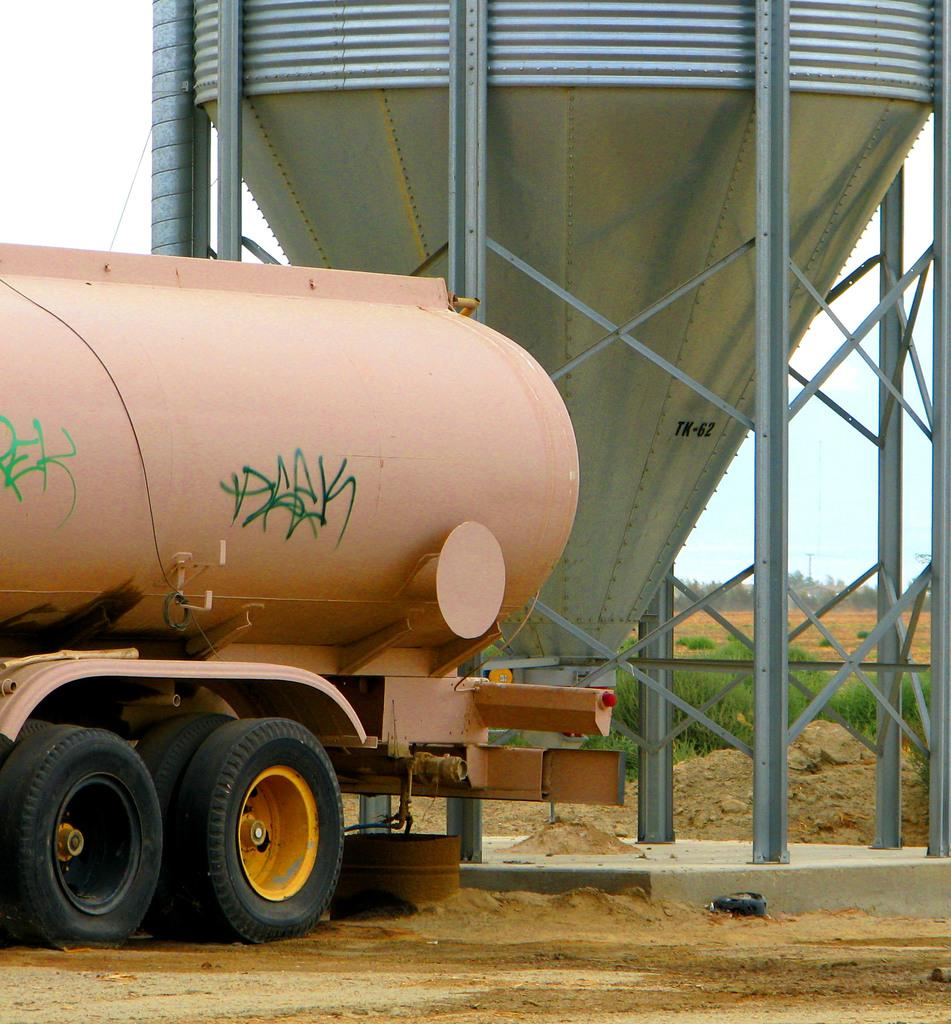What type of vehicle is present in the image? There is a vehicle with a tanker in the image. What is the container used for in the image? The container's purpose is not specified, but it is present in the image. What type of vegetation can be seen in the image? Plants and trees are visible in the image. What is visible in the distance in the image? Trees are visible in the distance in the image. How many dinosaurs are visible in the image? There are no dinosaurs present in the image. What word is written on the container in the image? The image does not show any words written on the container. 